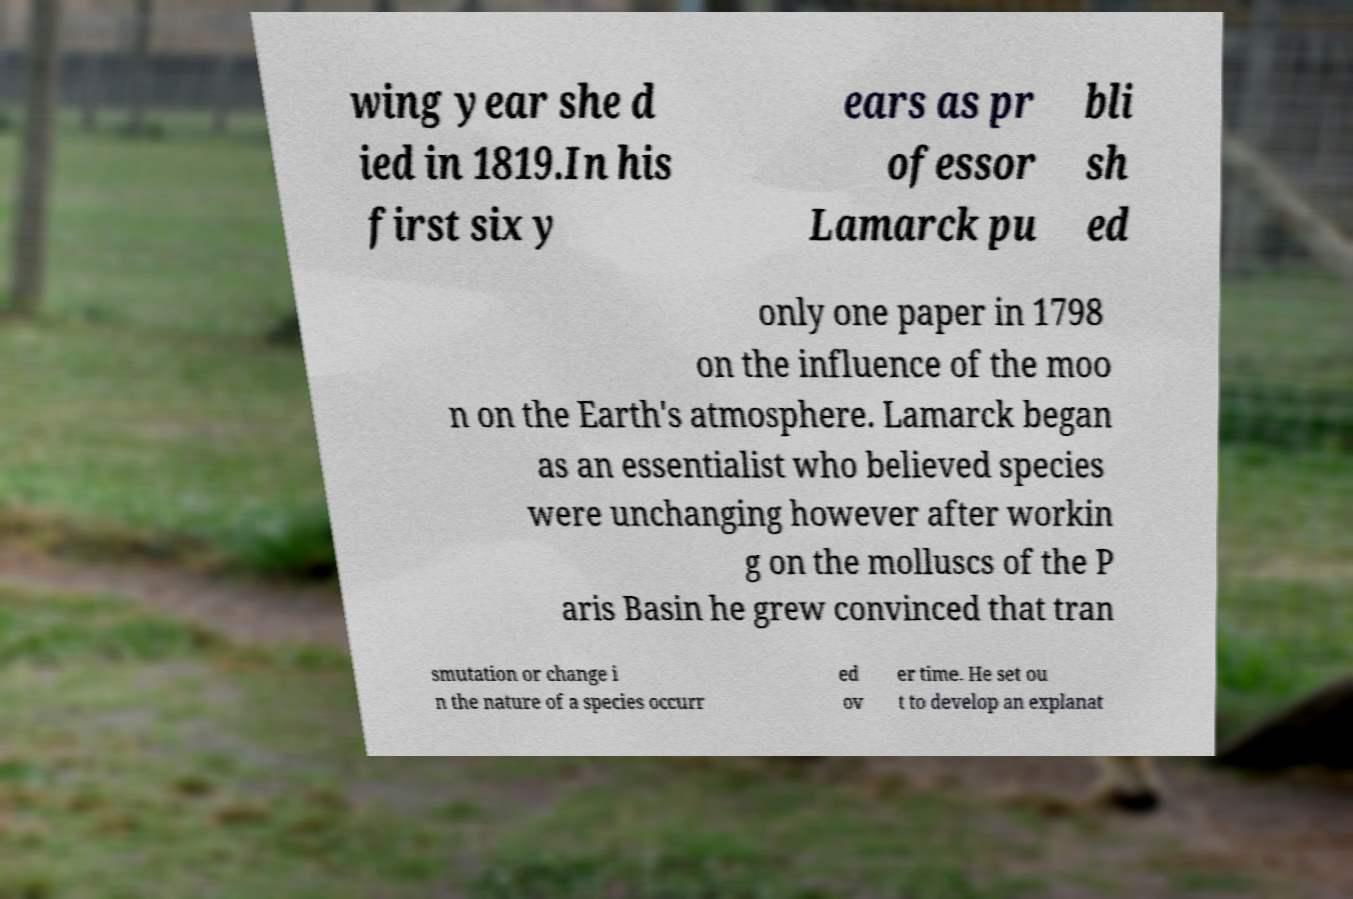Can you accurately transcribe the text from the provided image for me? wing year she d ied in 1819.In his first six y ears as pr ofessor Lamarck pu bli sh ed only one paper in 1798 on the influence of the moo n on the Earth's atmosphere. Lamarck began as an essentialist who believed species were unchanging however after workin g on the molluscs of the P aris Basin he grew convinced that tran smutation or change i n the nature of a species occurr ed ov er time. He set ou t to develop an explanat 